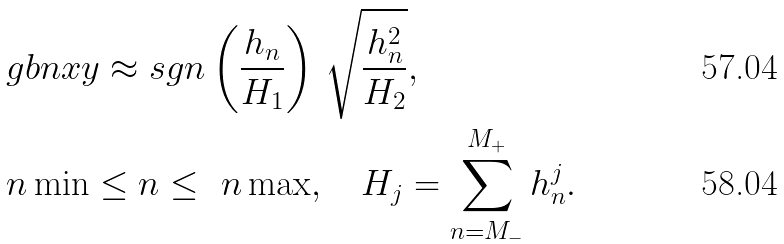Convert formula to latex. <formula><loc_0><loc_0><loc_500><loc_500>& \ g b n x y \approx s g n \left ( \frac { h _ { n } } { H _ { 1 } } \right ) \, \sqrt { \frac { h _ { n } ^ { 2 } } { H _ { 2 } } } , \\ & \ n \min \leq n \leq \ n \max , \quad H _ { j } = \sum _ { n = M _ { - } } ^ { M _ { + } } h _ { n } ^ { j } .</formula> 